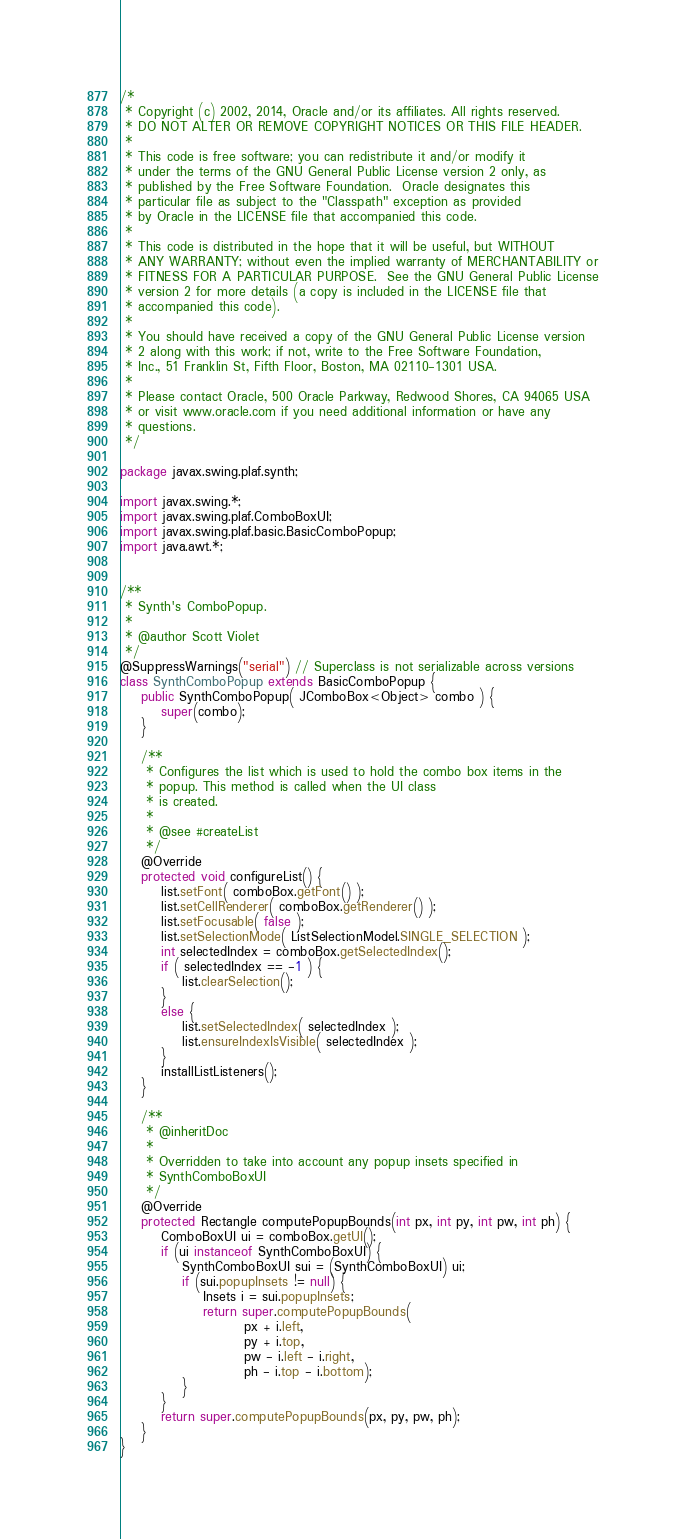<code> <loc_0><loc_0><loc_500><loc_500><_Java_>/*
 * Copyright (c) 2002, 2014, Oracle and/or its affiliates. All rights reserved.
 * DO NOT ALTER OR REMOVE COPYRIGHT NOTICES OR THIS FILE HEADER.
 *
 * This code is free software; you can redistribute it and/or modify it
 * under the terms of the GNU General Public License version 2 only, as
 * published by the Free Software Foundation.  Oracle designates this
 * particular file as subject to the "Classpath" exception as provided
 * by Oracle in the LICENSE file that accompanied this code.
 *
 * This code is distributed in the hope that it will be useful, but WITHOUT
 * ANY WARRANTY; without even the implied warranty of MERCHANTABILITY or
 * FITNESS FOR A PARTICULAR PURPOSE.  See the GNU General Public License
 * version 2 for more details (a copy is included in the LICENSE file that
 * accompanied this code).
 *
 * You should have received a copy of the GNU General Public License version
 * 2 along with this work; if not, write to the Free Software Foundation,
 * Inc., 51 Franklin St, Fifth Floor, Boston, MA 02110-1301 USA.
 *
 * Please contact Oracle, 500 Oracle Parkway, Redwood Shores, CA 94065 USA
 * or visit www.oracle.com if you need additional information or have any
 * questions.
 */

package javax.swing.plaf.synth;

import javax.swing.*;
import javax.swing.plaf.ComboBoxUI;
import javax.swing.plaf.basic.BasicComboPopup;
import java.awt.*;


/**
 * Synth's ComboPopup.
 *
 * @author Scott Violet
 */
@SuppressWarnings("serial") // Superclass is not serializable across versions
class SynthComboPopup extends BasicComboPopup {
    public SynthComboPopup( JComboBox<Object> combo ) {
        super(combo);
    }

    /**
     * Configures the list which is used to hold the combo box items in the
     * popup. This method is called when the UI class
     * is created.
     *
     * @see #createList
     */
    @Override
    protected void configureList() {
        list.setFont( comboBox.getFont() );
        list.setCellRenderer( comboBox.getRenderer() );
        list.setFocusable( false );
        list.setSelectionMode( ListSelectionModel.SINGLE_SELECTION );
        int selectedIndex = comboBox.getSelectedIndex();
        if ( selectedIndex == -1 ) {
            list.clearSelection();
        }
        else {
            list.setSelectedIndex( selectedIndex );
            list.ensureIndexIsVisible( selectedIndex );
        }
        installListListeners();
    }

    /**
     * @inheritDoc
     *
     * Overridden to take into account any popup insets specified in
     * SynthComboBoxUI
     */
    @Override
    protected Rectangle computePopupBounds(int px, int py, int pw, int ph) {
        ComboBoxUI ui = comboBox.getUI();
        if (ui instanceof SynthComboBoxUI) {
            SynthComboBoxUI sui = (SynthComboBoxUI) ui;
            if (sui.popupInsets != null) {
                Insets i = sui.popupInsets;
                return super.computePopupBounds(
                        px + i.left,
                        py + i.top,
                        pw - i.left - i.right,
                        ph - i.top - i.bottom);
            }
        }
        return super.computePopupBounds(px, py, pw, ph);
    }
}
</code> 